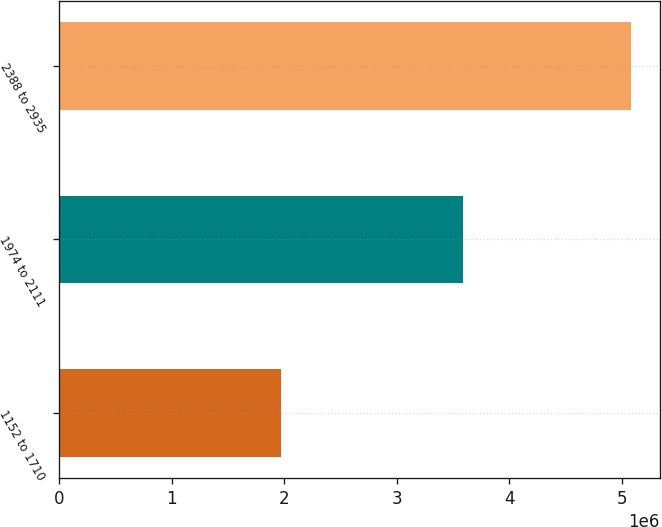Convert chart to OTSL. <chart><loc_0><loc_0><loc_500><loc_500><bar_chart><fcel>1152 to 1710<fcel>1974 to 2111<fcel>2388 to 2935<nl><fcel>1.97259e+06<fcel>3.58646e+06<fcel>5.0797e+06<nl></chart> 